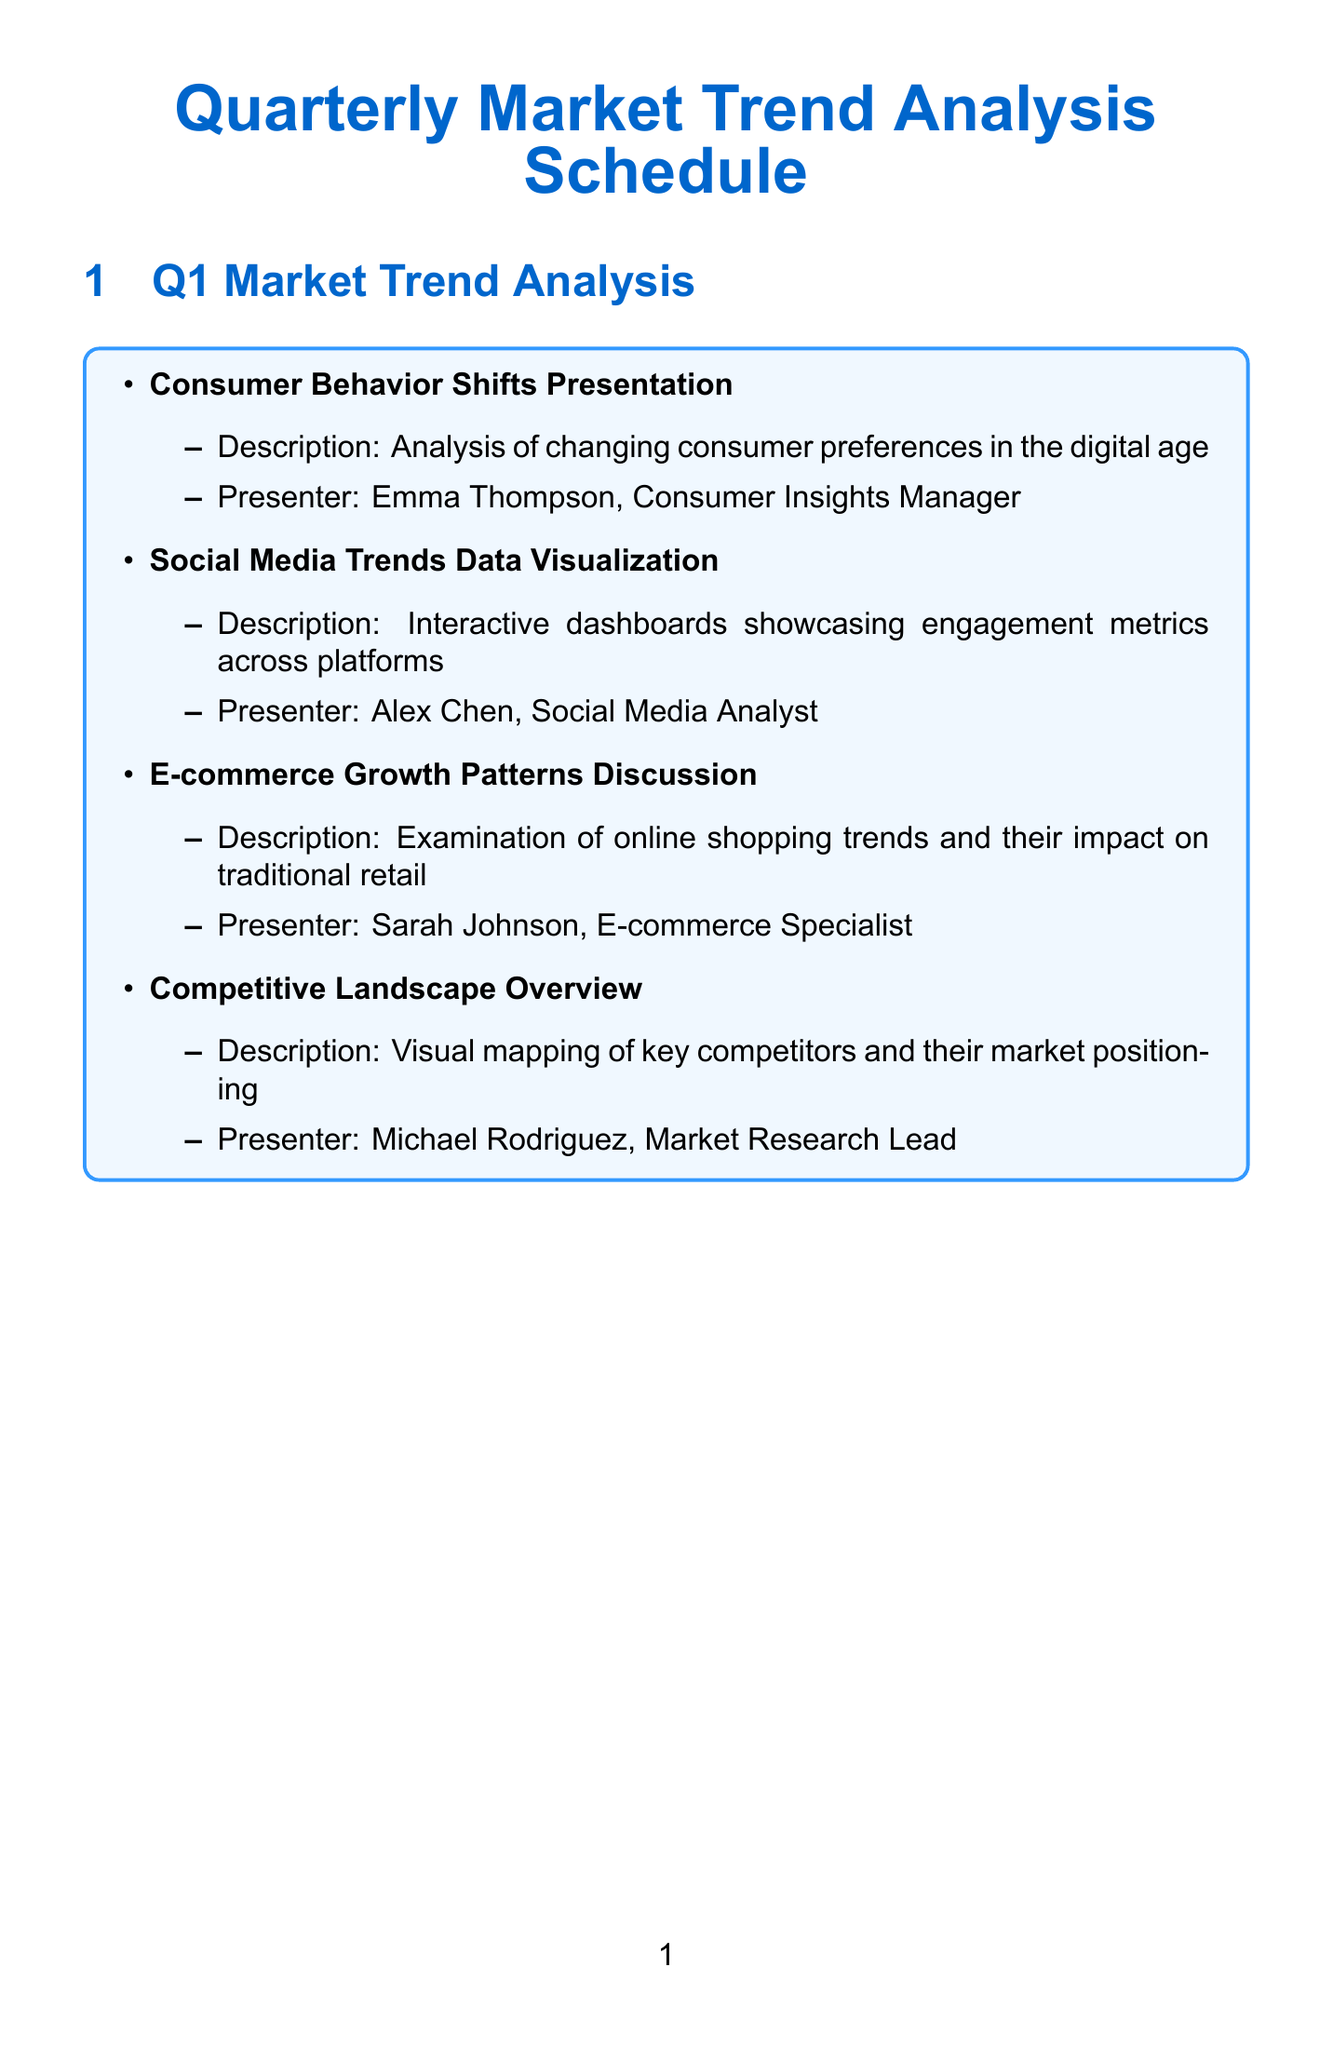What is the first activity in Q1? The first activity listed in Q1 is "Consumer Behavior Shifts Presentation."
Answer: Consumer Behavior Shifts Presentation Who presents the Social Media Trends Data Visualization? The presenter for this activity is Alex Chen.
Answer: Alex Chen What technology is used for cross-channel marketing performance reports? The document states that Google Data Studio is used for this purpose.
Answer: Google Data Studio How many components are there in Q3 Market Trend Analysis? Q3 includes four activities or components in the analysis.
Answer: Four What is the focus of the Q2 presentation by Dr. Rajesh Patel? Dr. Rajesh Patel focuses on the impact of emerging technologies on consumer behavior.
Answer: Emerging technologies Which quarter includes the Holiday Shopping Forecast analysis? The Holiday Shopping Forecast analysis is included in Q4.
Answer: Q4 What task is the responsibility of the Data Analysis Team? The Data Analysis Team is responsible for data collection and cleaning.
Answer: Data Collection and Cleaning How many data visualization tools are mentioned in the document? The document mentions four data visualization tools.
Answer: Four What is the name of the presenter for the Annual Consumer Confidence Index Review? The presenter for this review is Dr. Elizabeth Moore.
Answer: Dr. Elizabeth Moore 